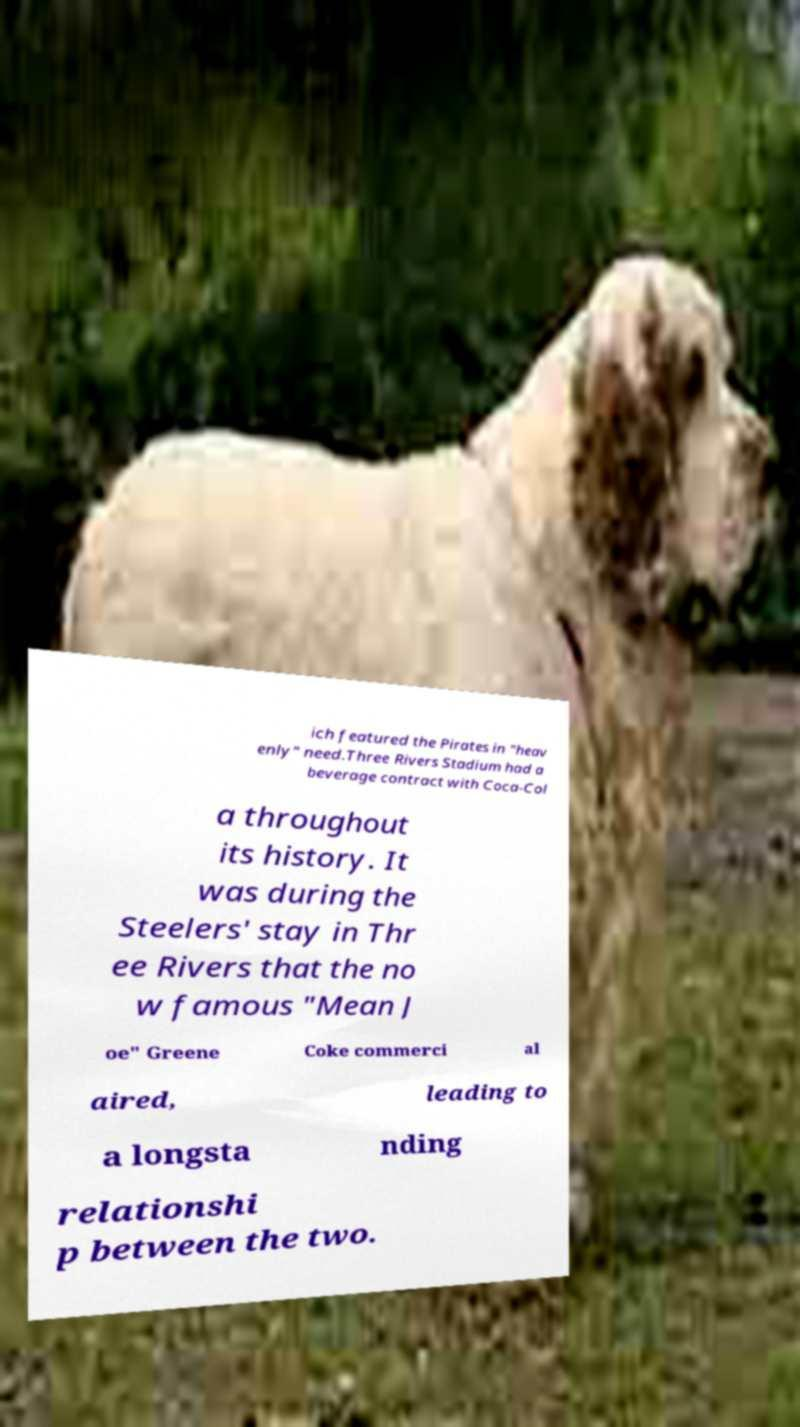Could you assist in decoding the text presented in this image and type it out clearly? ich featured the Pirates in "heav enly" need.Three Rivers Stadium had a beverage contract with Coca-Col a throughout its history. It was during the Steelers' stay in Thr ee Rivers that the no w famous "Mean J oe" Greene Coke commerci al aired, leading to a longsta nding relationshi p between the two. 